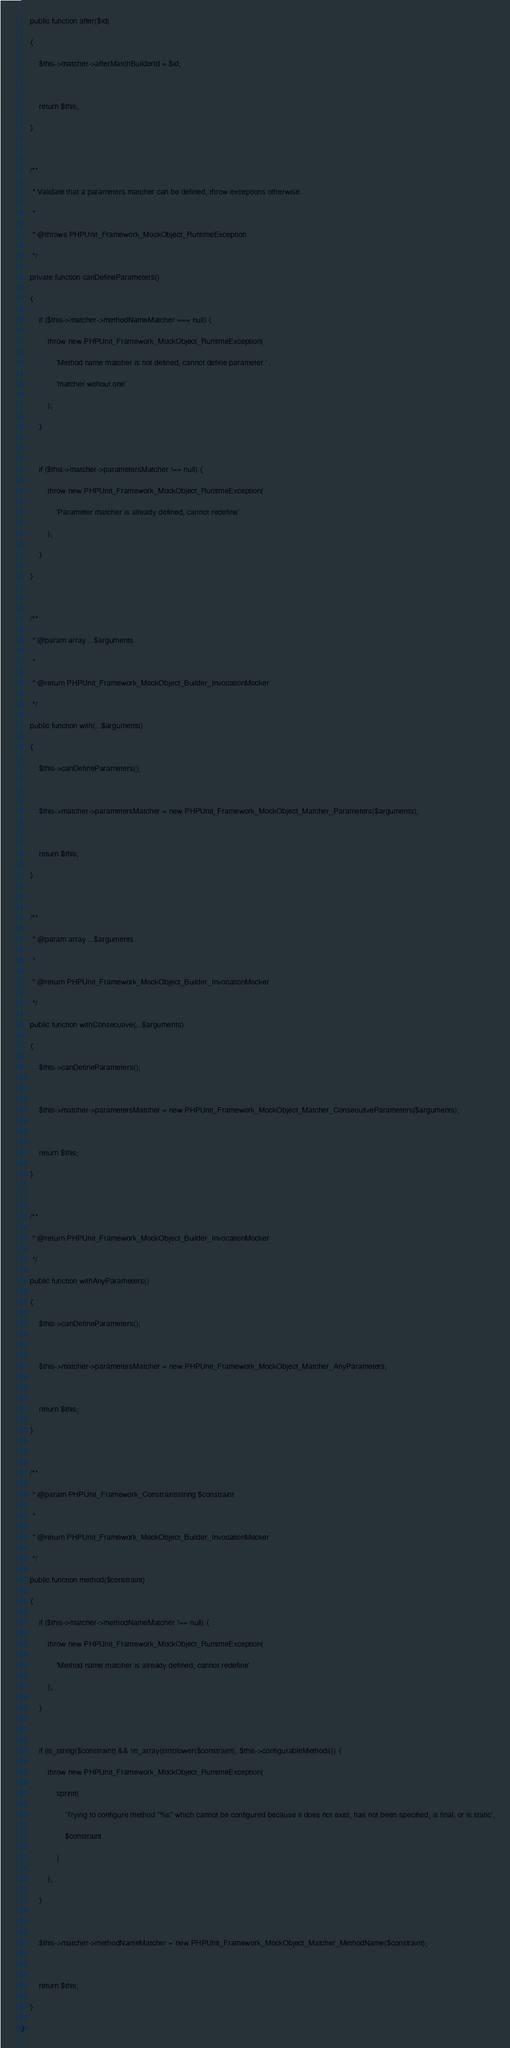Convert code to text. <code><loc_0><loc_0><loc_500><loc_500><_PHP_>    public function after($id)
    {
        $this->matcher->afterMatchBuilderId = $id;

        return $this;
    }

    /**
     * Validate that a parameters matcher can be defined, throw exceptions otherwise.
     *
     * @throws PHPUnit_Framework_MockObject_RuntimeException
     */
    private function canDefineParameters()
    {
        if ($this->matcher->methodNameMatcher === null) {
            throw new PHPUnit_Framework_MockObject_RuntimeException(
                'Method name matcher is not defined, cannot define parameter ' .
                'matcher without one'
            );
        }

        if ($this->matcher->parametersMatcher !== null) {
            throw new PHPUnit_Framework_MockObject_RuntimeException(
                'Parameter matcher is already defined, cannot redefine'
            );
        }
    }

    /**
     * @param array ...$arguments
     *
     * @return PHPUnit_Framework_MockObject_Builder_InvocationMocker
     */
    public function with(...$arguments)
    {
        $this->canDefineParameters();

        $this->matcher->parametersMatcher = new PHPUnit_Framework_MockObject_Matcher_Parameters($arguments);

        return $this;
    }

    /**
     * @param array ...$arguments
     *
     * @return PHPUnit_Framework_MockObject_Builder_InvocationMocker
     */
    public function withConsecutive(...$arguments)
    {
        $this->canDefineParameters();

        $this->matcher->parametersMatcher = new PHPUnit_Framework_MockObject_Matcher_ConsecutiveParameters($arguments);

        return $this;
    }

    /**
     * @return PHPUnit_Framework_MockObject_Builder_InvocationMocker
     */
    public function withAnyParameters()
    {
        $this->canDefineParameters();

        $this->matcher->parametersMatcher = new PHPUnit_Framework_MockObject_Matcher_AnyParameters;

        return $this;
    }

    /**
     * @param PHPUnit_Framework_Constraint|string $constraint
     *
     * @return PHPUnit_Framework_MockObject_Builder_InvocationMocker
     */
    public function method($constraint)
    {
        if ($this->matcher->methodNameMatcher !== null) {
            throw new PHPUnit_Framework_MockObject_RuntimeException(
                'Method name matcher is already defined, cannot redefine'
            );
        }

        if (is_string($constraint) && !in_array(strtolower($constraint), $this->configurableMethods)) {
            throw new PHPUnit_Framework_MockObject_RuntimeException(
                sprintf(
                    'Trying to configure method "%s" which cannot be configured because it does not exist, has not been specified, is final, or is static',
                    $constraint
                )
            );
        }

        $this->matcher->methodNameMatcher = new PHPUnit_Framework_MockObject_Matcher_MethodName($constraint);

        return $this;
    }
}
</code> 